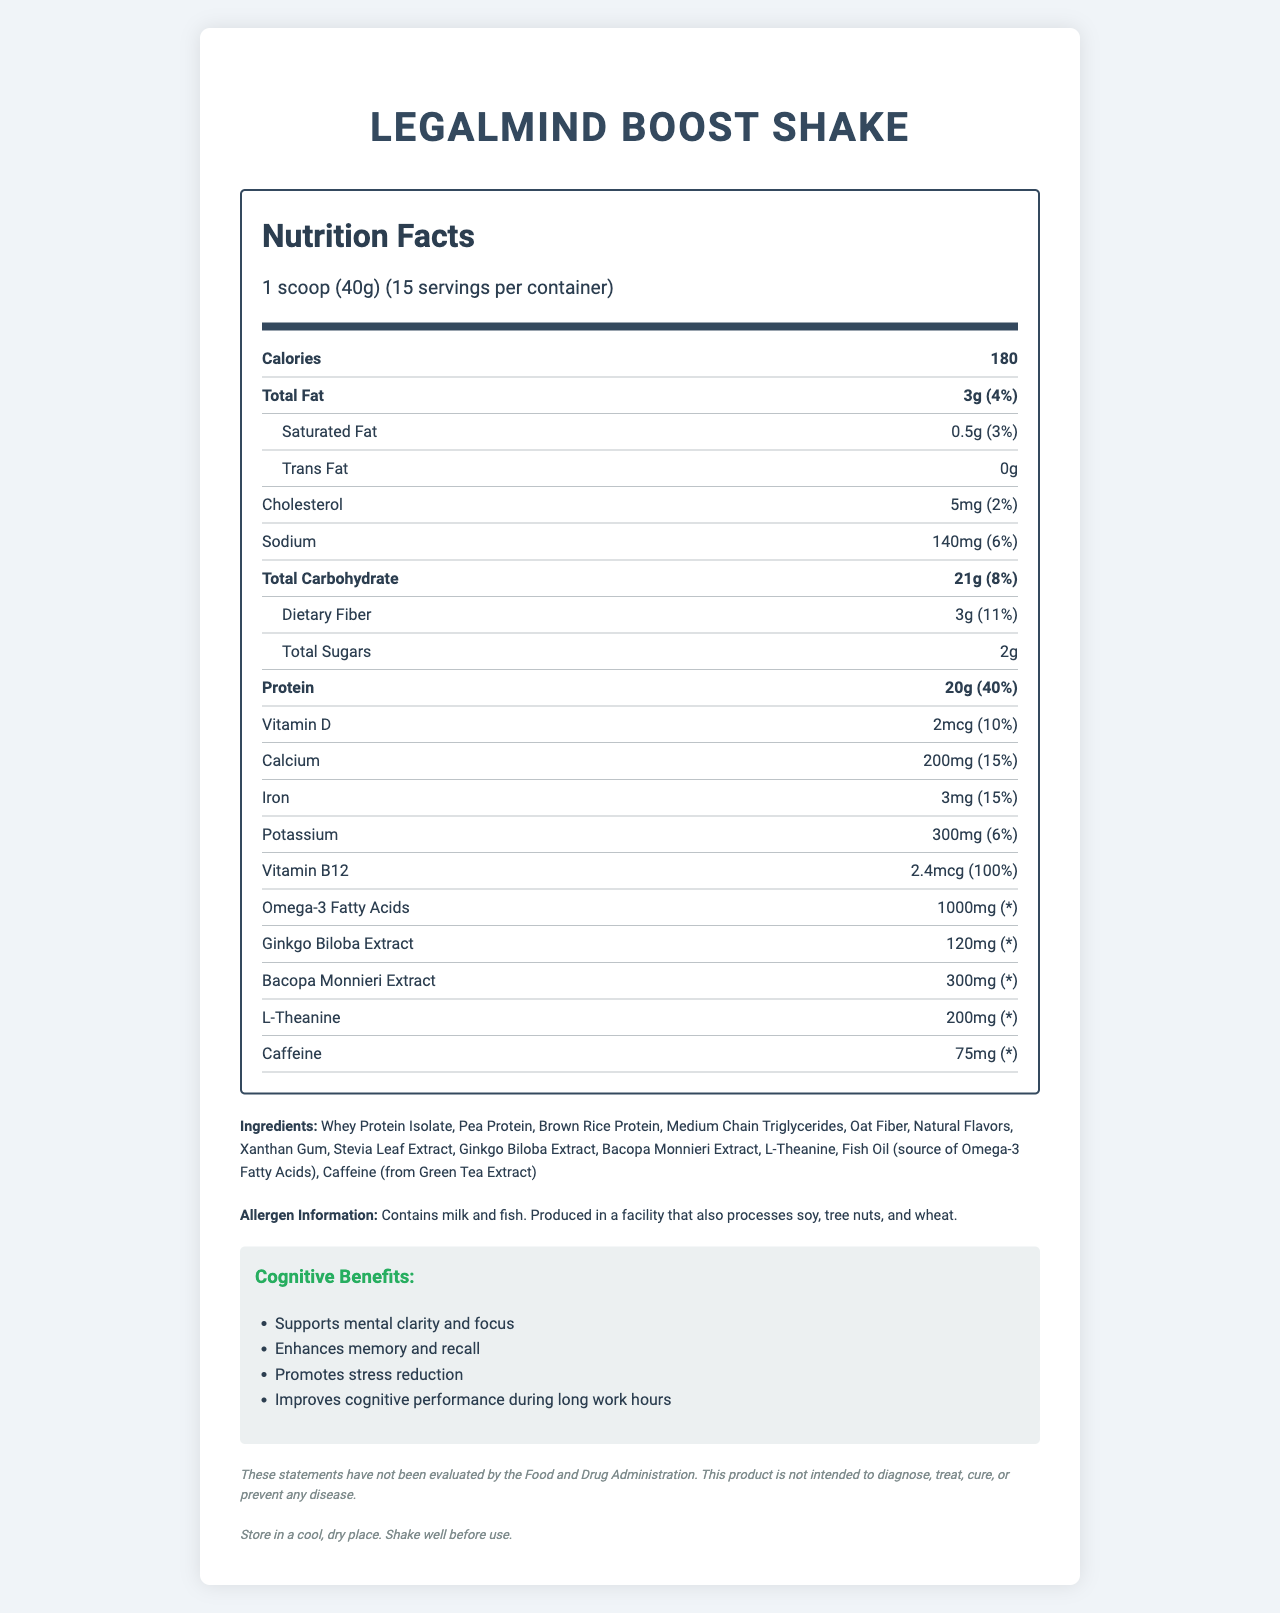What is the serving size of the LegalMind Boost Shake? The serving size is stated at the top of the nutrition label as "1 scoop (40g)".
Answer: 1 scoop (40g) How many servings are in one container of the LegalMind Boost Shake? The number of servings per container is mentioned right after the serving size on the nutrition label.
Answer: 15 What is the calorie content per serving of the LegalMind Boost Shake? The calorie content per serving is listed in the bold section under "Calories".
Answer: 180 How many grams of protein are in one serving? The protein amount is listed in the bold section under "Protein".
Answer: 20g What are the main cognitive benefits of the LegalMind Boost Shake? These benefits are highlighted in the "Cognitive Benefits" section of the document.
Answer: Supports mental clarity and focus, Enhances memory and recall, Promotes stress reduction, Improves cognitive performance during long work hours How much caffeine does one serving contain? The amount of caffeine is listed under the nutrition label section for "Caffeine".
Answer: 75mg What are the two primary allergens listed in the LegalMind Boost Shake? The allergen information states the product contains milk and fish.
Answer: Milk and Fish Which of the following is a benefit of the LegalMind Boost Shake? A) Improves digestion B) Enhances memory C) Supports weight loss The document lists "Enhances memory and recall" as one of the cognitive benefits.
Answer: B) Enhances memory What percentage of the daily value of protein does one serving provide? A) 20% B) 40% C) 15% D) 10% According to the protein section, one serving provides 40% of the daily value.
Answer: B) 40% Does the LegalMind Boost Shake contain trans fat? Yes/No The nutrition information specifically lists Trans Fat as "0g".
Answer: No Summarize the main nutritional information and benefits of the LegalMind Boost Shake. The document provides a detailed nutrition label, highlights cognitive benefits, and includes allergen information, serving size, and storage instructions.
Answer: The LegalMind Boost Shake provides 180 calories per serving, with key nutrients such as 20g of protein, 3g of fat, and 21g of carbohydrates. It is formulated with cognitive-enhancing ingredients to support mental clarity, memory, and stress reduction, making it suitable for legal professionals during long work hours. The product contains milk and fish allergens. What are the precise percentages of daily values for vitamins and minerals in the product? Though the document lists amounts and some daily values (like Vitamin D, Calcium, Iron, and Vitamin B12), it does not include this information for all vitamins and minerals present in the product.
Answer: Not enough information 